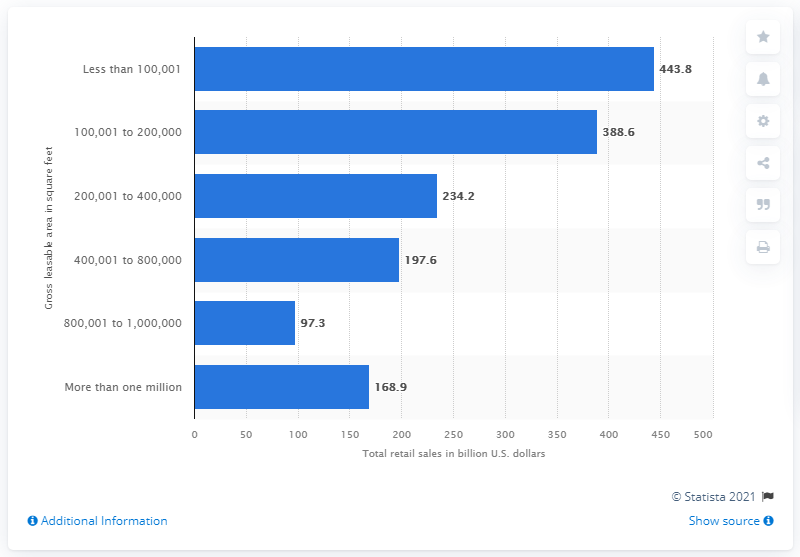Point out several critical features in this image. According to the data provided, the total retail sales of shopping malls between 200,001 and 400,000 square feet in 2005 was 234.2 billion dollars. 